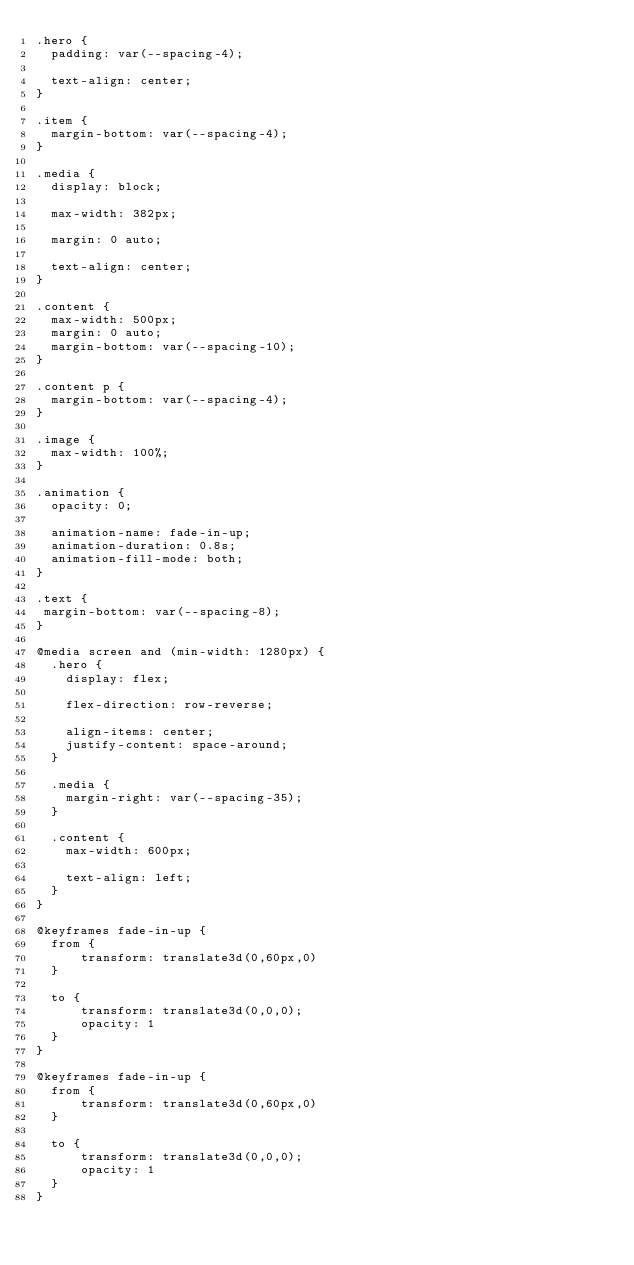<code> <loc_0><loc_0><loc_500><loc_500><_CSS_>.hero {
  padding: var(--spacing-4);

  text-align: center;
}

.item {
  margin-bottom: var(--spacing-4);
}

.media {
  display: block;

  max-width: 382px;

  margin: 0 auto;

  text-align: center;
}

.content {
  max-width: 500px;
  margin: 0 auto;
  margin-bottom: var(--spacing-10);
}

.content p {
  margin-bottom: var(--spacing-4);
}

.image {
  max-width: 100%;
}

.animation {
  opacity: 0;

  animation-name: fade-in-up;
  animation-duration: 0.8s;
  animation-fill-mode: both;
}

.text {
 margin-bottom: var(--spacing-8);
}

@media screen and (min-width: 1280px) {
  .hero {
    display: flex;

    flex-direction: row-reverse;

    align-items: center;
    justify-content: space-around;
  }

  .media {
    margin-right: var(--spacing-35);
  }

  .content {
    max-width: 600px;

    text-align: left;
  }
}

@keyframes fade-in-up {
  from {
      transform: translate3d(0,60px,0)
  }

  to {
      transform: translate3d(0,0,0);
      opacity: 1
  }
}

@keyframes fade-in-up {
  from {
      transform: translate3d(0,60px,0)
  }

  to {
      transform: translate3d(0,0,0);
      opacity: 1
  }
}</code> 